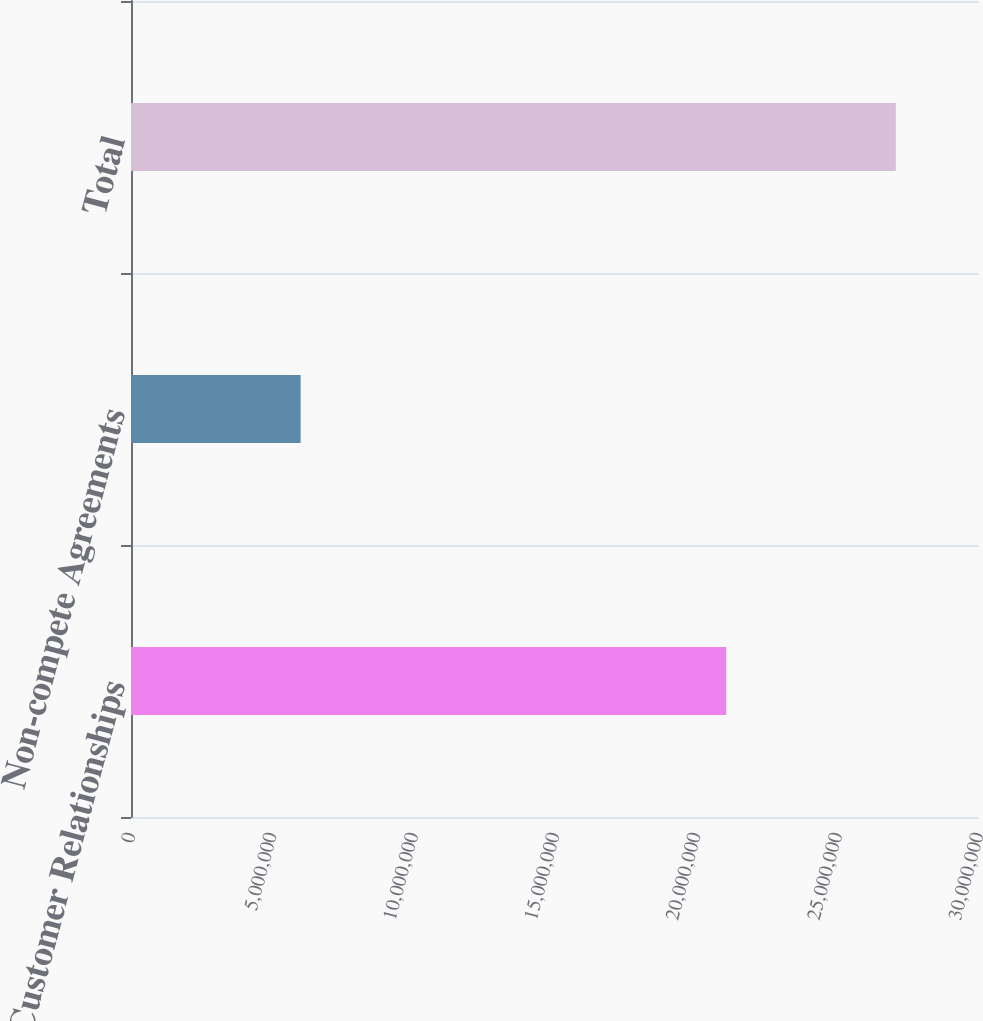Convert chart. <chart><loc_0><loc_0><loc_500><loc_500><bar_chart><fcel>Customer Relationships<fcel>Non-compete Agreements<fcel>Total<nl><fcel>2.1056e+07<fcel>6.001e+06<fcel>2.7057e+07<nl></chart> 